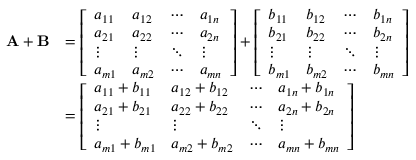Convert formula to latex. <formula><loc_0><loc_0><loc_500><loc_500>{ \begin{array} { r l } { A + B } & { = { \left [ \begin{array} { l l l l } { a _ { 1 1 } } & { a _ { 1 2 } } & { \cdots } & { a _ { 1 n } } \\ { a _ { 2 1 } } & { a _ { 2 2 } } & { \cdots } & { a _ { 2 n } } \\ { \vdots } & { \vdots } & { \ddots } & { \vdots } \\ { a _ { m 1 } } & { a _ { m 2 } } & { \cdots } & { a _ { m n } } \end{array} \right ] } + { \left [ \begin{array} { l l l l } { b _ { 1 1 } } & { b _ { 1 2 } } & { \cdots } & { b _ { 1 n } } \\ { b _ { 2 1 } } & { b _ { 2 2 } } & { \cdots } & { b _ { 2 n } } \\ { \vdots } & { \vdots } & { \ddots } & { \vdots } \\ { b _ { m 1 } } & { b _ { m 2 } } & { \cdots } & { b _ { m n } } \end{array} \right ] } } \\ & { = { \left [ \begin{array} { l l l l } { a _ { 1 1 } + b _ { 1 1 } } & { a _ { 1 2 } + b _ { 1 2 } } & { \cdots } & { a _ { 1 n } + b _ { 1 n } } \\ { a _ { 2 1 } + b _ { 2 1 } } & { a _ { 2 2 } + b _ { 2 2 } } & { \cdots } & { a _ { 2 n } + b _ { 2 n } } \\ { \vdots } & { \vdots } & { \ddots } & { \vdots } \\ { a _ { m 1 } + b _ { m 1 } } & { a _ { m 2 } + b _ { m 2 } } & { \cdots } & { a _ { m n } + b _ { m n } } \end{array} \right ] } } \end{array} }</formula> 